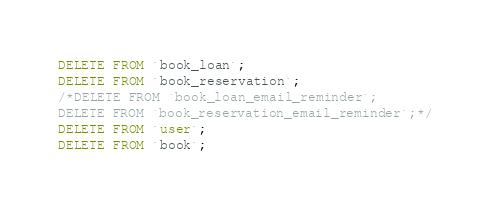Convert code to text. <code><loc_0><loc_0><loc_500><loc_500><_SQL_>DELETE FROM `book_loan`;
DELETE FROM `book_reservation`;
/*DELETE FROM `book_loan_email_reminder`;
DELETE FROM `book_reservation_email_reminder`;*/
DELETE FROM `user`;
DELETE FROM `book`;</code> 